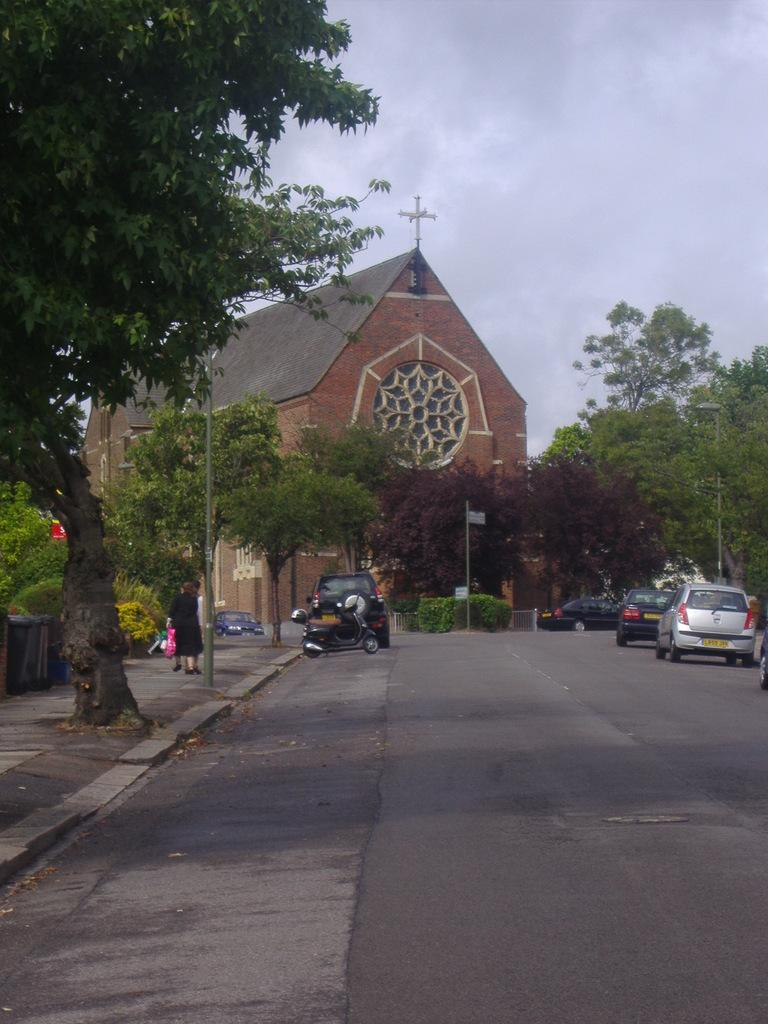What can be seen in the middle of the image? There are trees, poles, a fence, a group of people, and fleets of cars on the road in the middle of the image. What is present in the background of the image? There is a house and the sky visible in the background of the image. When was the image taken? The image was taken during the day. Can you see any tramp in the image? There is no tramp present in the image. Is there a body of water visible in the image? No, there is no body of water visible in the image. What type of fowl can be seen in the image? There are no fowl present in the image. 